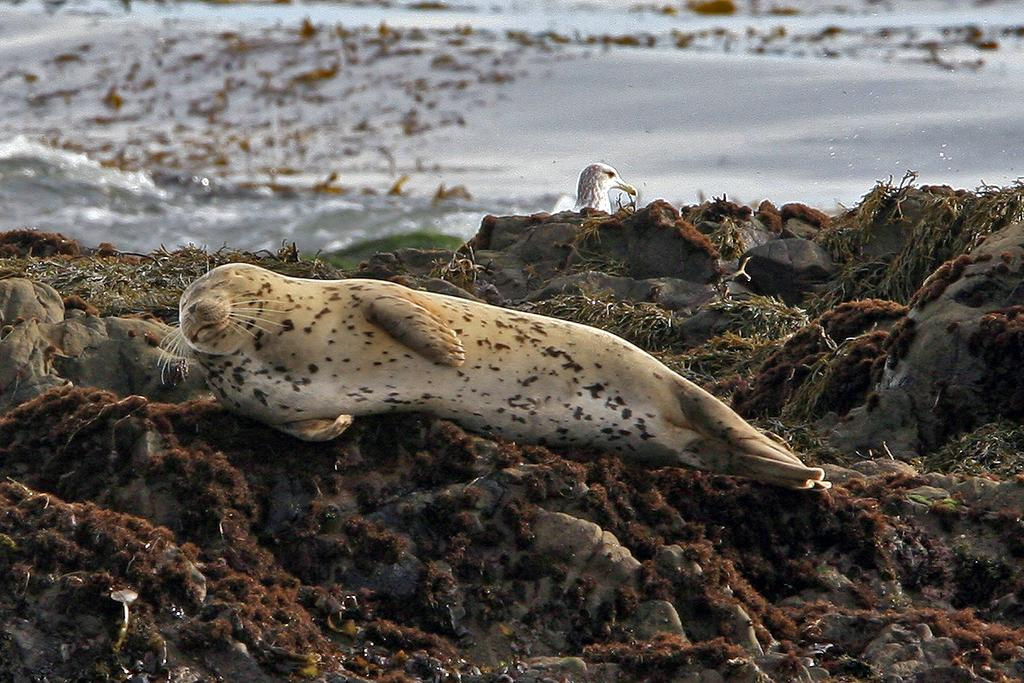What animal is the main subject of the image? There is a seal in the image. What colors can be seen on the seal? The seal is in cream and white color. What other animal can be seen in the background of the image? There is a bird in the background of the image. What color is the bird? The bird is in white color. What natural element is visible in the image? There is water visible in the image. How many beads are hanging from the cobweb in the image? There is no cobweb or beads present in the image. What type of zephyr can be seen blowing through the image? There is no zephyr present in the image; it is a still image of a seal and a bird. 